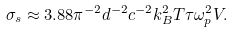<formula> <loc_0><loc_0><loc_500><loc_500>\sigma _ { s } \approx 3 . 8 8 \pi ^ { - 2 } d ^ { - 2 } c ^ { - 2 } k _ { B } ^ { 2 } T \tau \omega _ { p } ^ { 2 } V .</formula> 